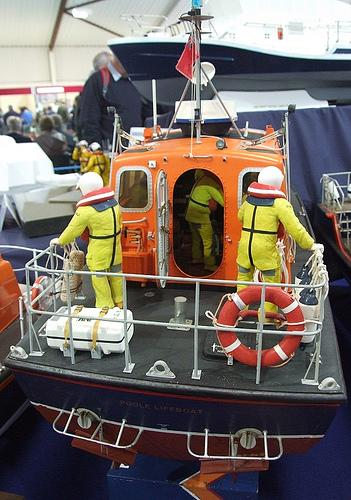How many people are on the boat?
Concise answer only. 3. What are the people doing?
Be succinct. Boating. What number of people are on the back of this boat?
Answer briefly. 2. 